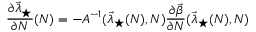Convert formula to latex. <formula><loc_0><loc_0><loc_500><loc_500>\frac { \partial \vec { \lambda } _ { ^ { * } } } { \partial N } ( N ) = - A ^ { - 1 } ( \vec { \lambda } _ { ^ { * } } ( N ) , N ) \frac { \partial \vec { \beta } } { \partial N } ( \vec { \lambda } _ { ^ { * } } ( N ) , N )</formula> 